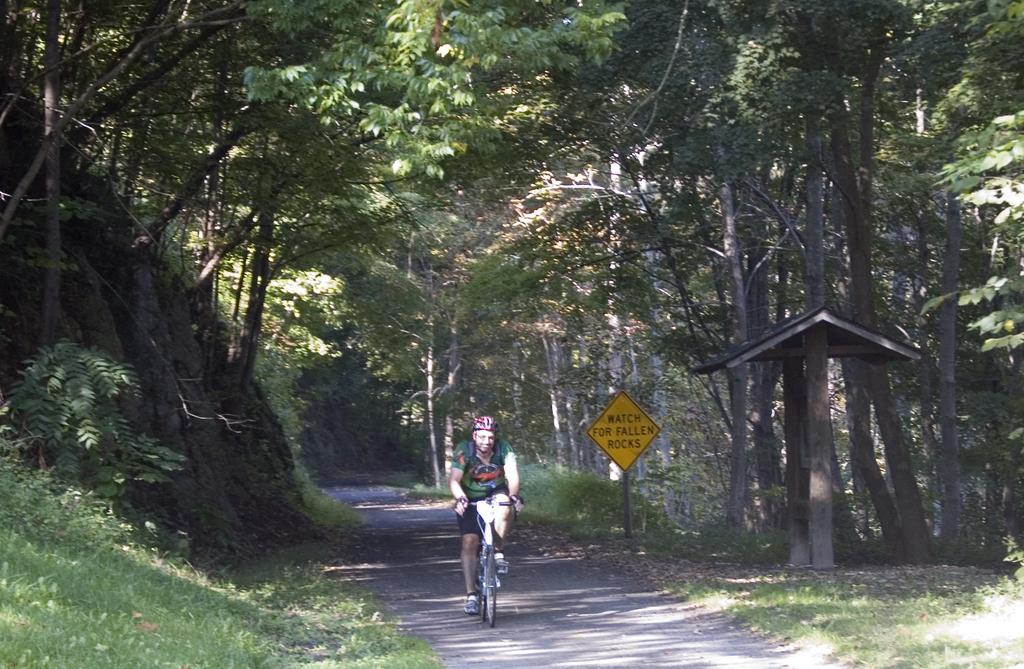What is the main subject in the foreground of the image? There is a person riding a bicycle in the foreground of the image. What surface is the person riding on? The person is riding on a road. What type of vegetation can be seen in the foreground of the image? Grass is visible in the foreground of the image. What structures are present in the foreground of the image? There is a board and a shed in the foreground of the image. What can be seen in the background of the image? Trees are present in the background of the image. What is the weather like in the image? The image appears to have been taken on a sunny day. What type of cable is being used for the operation in the image? There is no cable or operation present in the image; it features a person riding a bicycle on a road. 